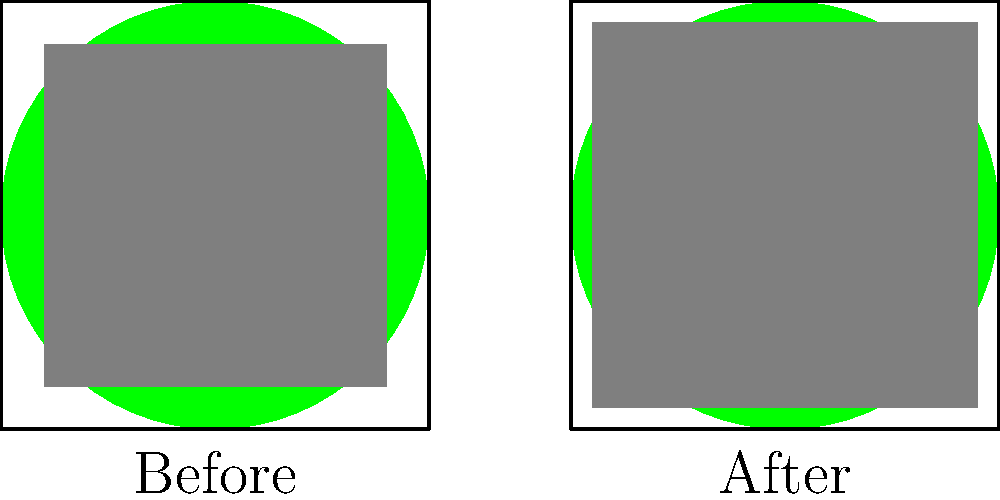Based on the before-and-after maps of a developing city, calculate the percentage decrease in green space area. Assume the total area of each map is 10,000 square units. To solve this problem, we'll follow these steps:

1. Calculate the total area of each map:
   Total area = 10,000 square units

2. Calculate the area of the gray square (developed area) in each map:
   - Before: $80 \times 80 = 6,400$ square units
   - After: $90 \times 90 = 8,100$ square units

3. Calculate the green space area in each map:
   - Before: $10,000 - 6,400 = 3,600$ square units
   - After: $10,000 - 8,100 = 1,900$ square units

4. Calculate the decrease in green space area:
   $3,600 - 1,900 = 1,700$ square units

5. Calculate the percentage decrease:
   Percentage decrease = $\frac{\text{Decrease}}{\text{Original}} \times 100\%$
   $= \frac{1,700}{3,600} \times 100\% \approx 47.22\%$

Therefore, the percentage decrease in green space area is approximately 47.22%.
Answer: 47.22% 